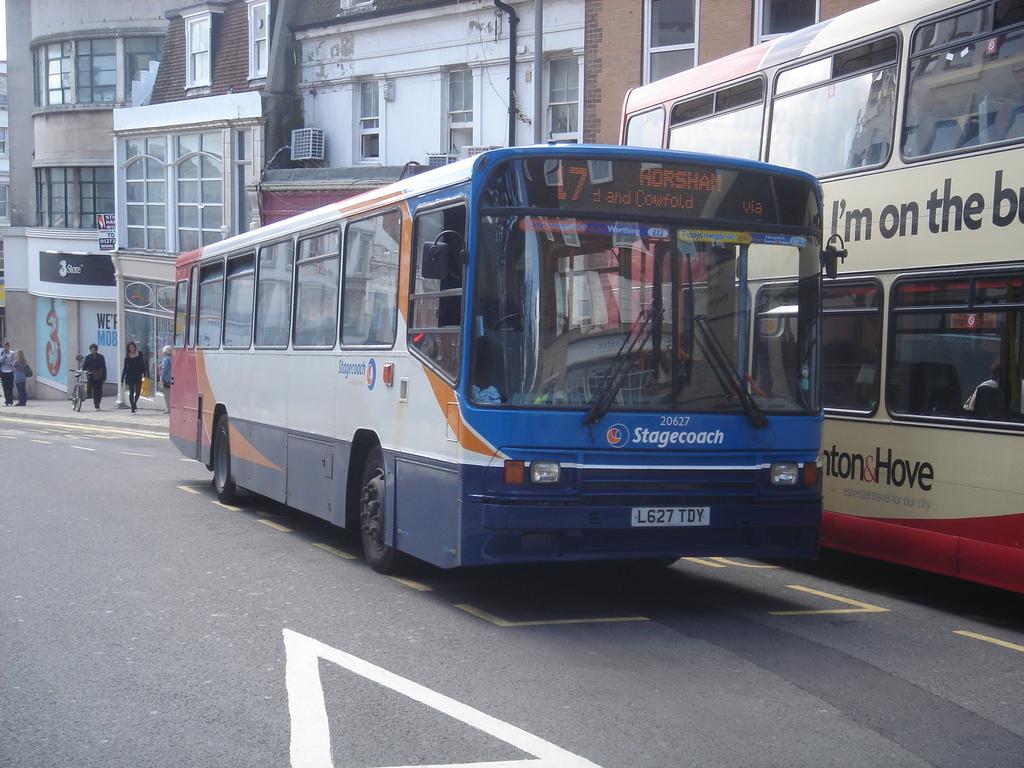What is the name of the bus?
Your response must be concise. Stagecoach. 